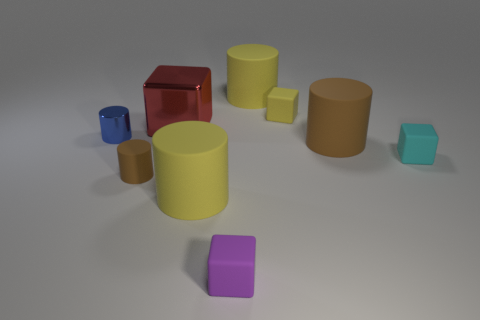Is the material of the yellow cylinder that is in front of the blue cylinder the same as the large block that is behind the tiny shiny object?
Your answer should be very brief. No. What color is the cylinder that is the same material as the large red object?
Your answer should be compact. Blue. Are there more large rubber objects that are behind the small yellow thing than small purple matte blocks that are right of the cyan matte object?
Offer a terse response. Yes. Is there a large red cylinder?
Offer a very short reply. No. There is a object that is the same color as the small matte cylinder; what is it made of?
Provide a short and direct response. Rubber. What number of objects are either large yellow rubber cylinders or metallic things?
Make the answer very short. 4. Are there any big cylinders of the same color as the small matte cylinder?
Your answer should be very brief. Yes. How many blocks are behind the tiny rubber object in front of the small brown cylinder?
Make the answer very short. 3. Is the number of small cyan things greater than the number of purple metallic blocks?
Your answer should be very brief. Yes. Is the tiny brown cylinder made of the same material as the small blue cylinder?
Your answer should be very brief. No. 